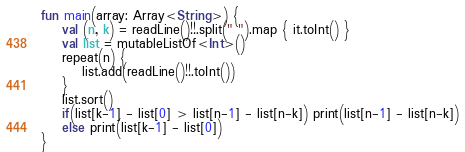Convert code to text. <code><loc_0><loc_0><loc_500><loc_500><_Kotlin_>fun main(array: Array<String>) {
    val (n, k) = readLine()!!.split(" ").map { it.toInt() }
    val list = mutableListOf<Int>()
    repeat(n) {
        list.add(readLine()!!.toInt())
    }
    list.sort()
    if(list[k-1] - list[0] > list[n-1] - list[n-k]) print(list[n-1] - list[n-k])
    else print(list[k-1] - list[0])
}</code> 